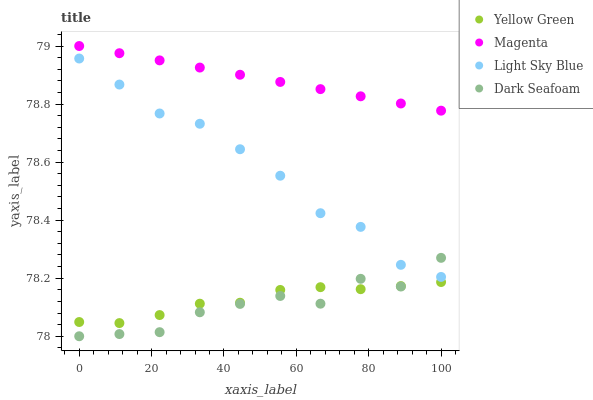Does Dark Seafoam have the minimum area under the curve?
Answer yes or no. Yes. Does Magenta have the maximum area under the curve?
Answer yes or no. Yes. Does Light Sky Blue have the minimum area under the curve?
Answer yes or no. No. Does Light Sky Blue have the maximum area under the curve?
Answer yes or no. No. Is Magenta the smoothest?
Answer yes or no. Yes. Is Dark Seafoam the roughest?
Answer yes or no. Yes. Is Light Sky Blue the smoothest?
Answer yes or no. No. Is Light Sky Blue the roughest?
Answer yes or no. No. Does Dark Seafoam have the lowest value?
Answer yes or no. Yes. Does Light Sky Blue have the lowest value?
Answer yes or no. No. Does Magenta have the highest value?
Answer yes or no. Yes. Does Light Sky Blue have the highest value?
Answer yes or no. No. Is Yellow Green less than Magenta?
Answer yes or no. Yes. Is Magenta greater than Dark Seafoam?
Answer yes or no. Yes. Does Yellow Green intersect Dark Seafoam?
Answer yes or no. Yes. Is Yellow Green less than Dark Seafoam?
Answer yes or no. No. Is Yellow Green greater than Dark Seafoam?
Answer yes or no. No. Does Yellow Green intersect Magenta?
Answer yes or no. No. 